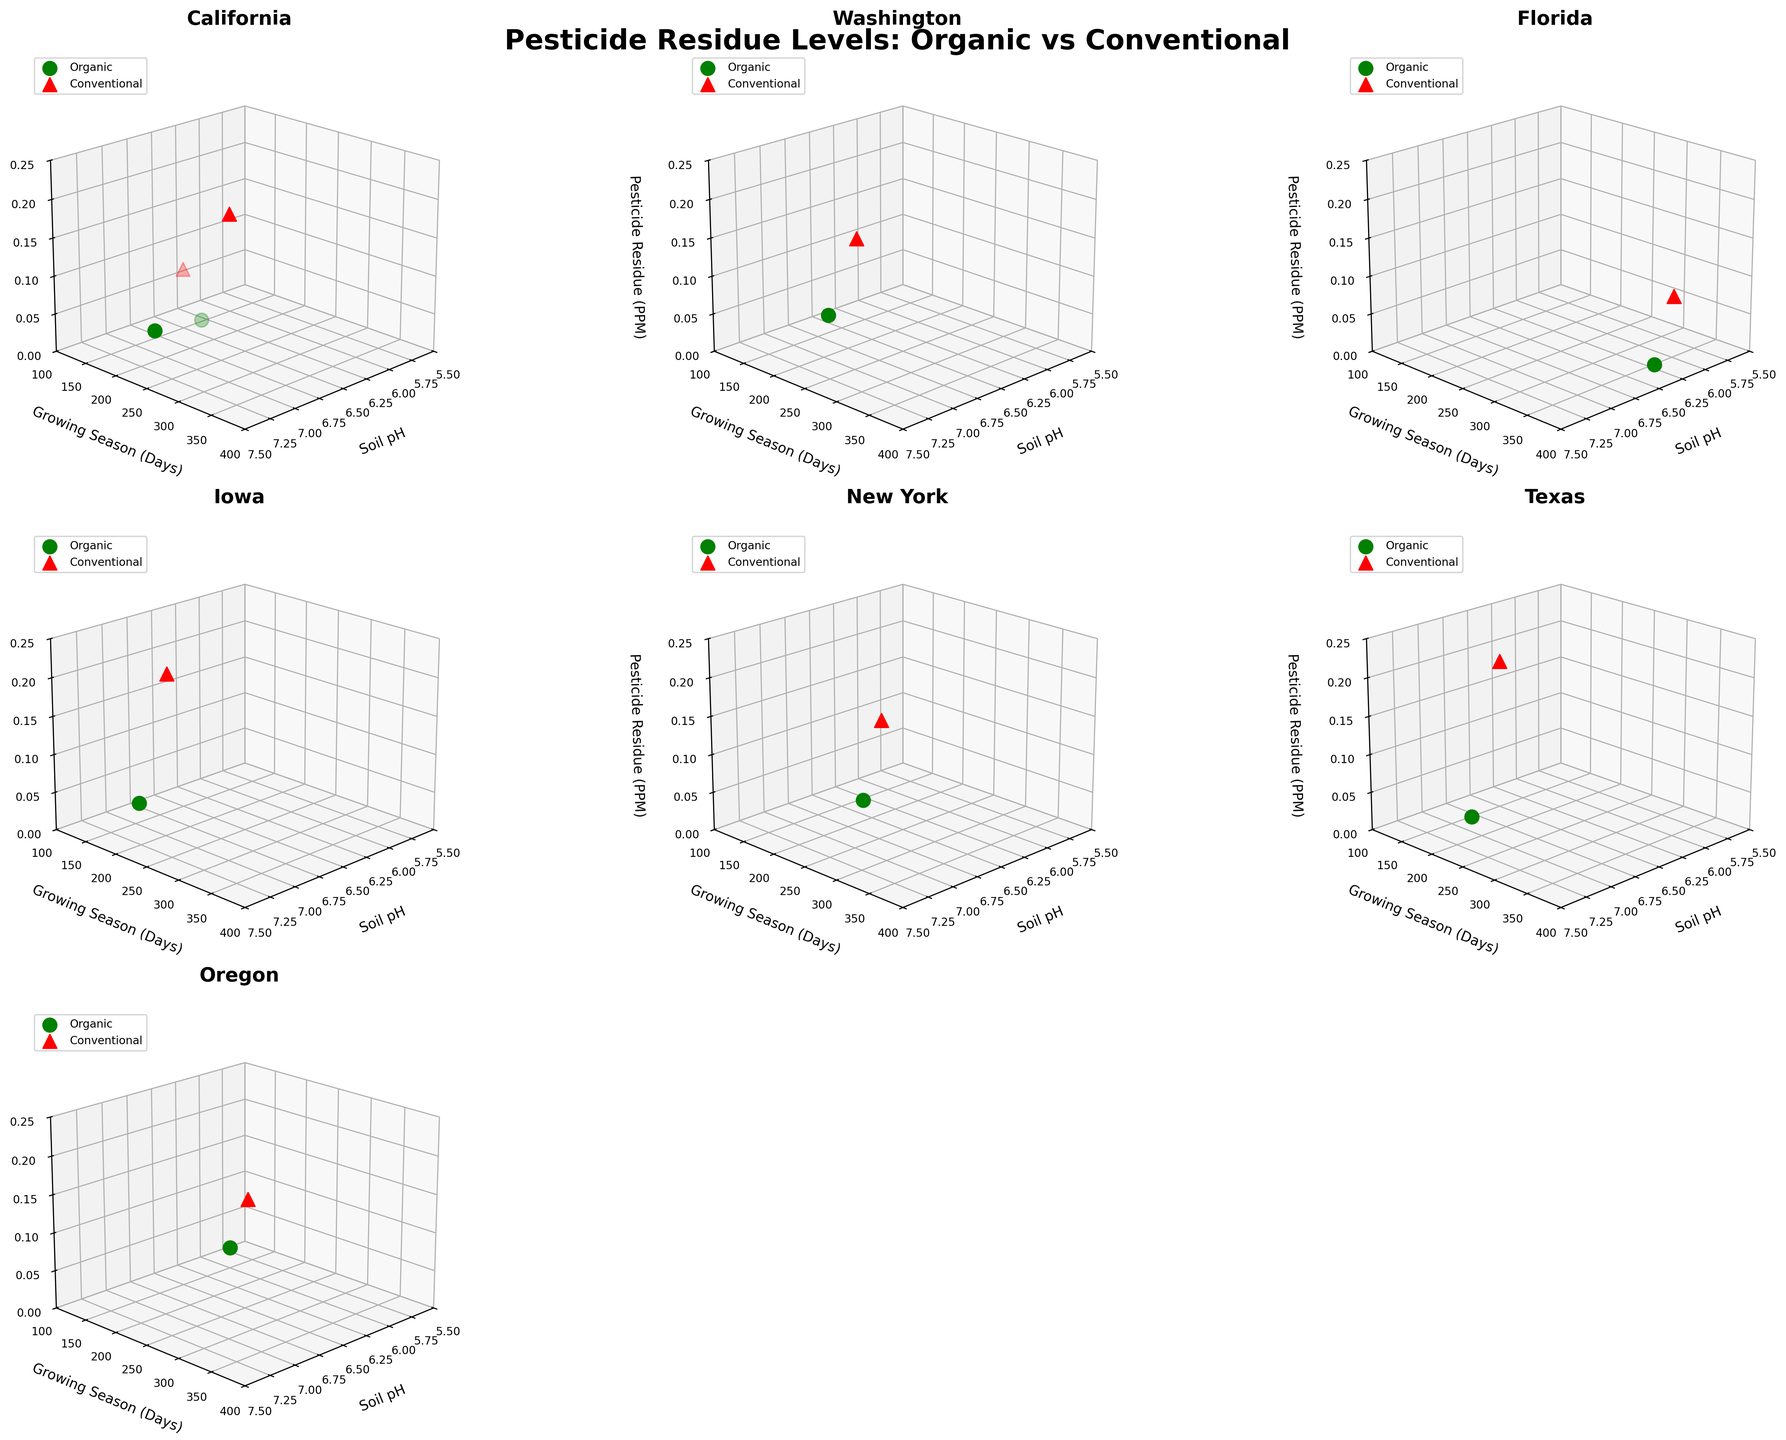what is the title of the overall figure? Look at the center of the figure above the individual subplots, which typically displays the title. Here, it says "Pesticide Residue Levels: Organic vs Conventional".
Answer: Pesticide Residue Levels: Organic vs Conventional Which region has the highest pesticide residue in conventional farming? Identify the subplots showing different regions, then look for the highest red marker which indicates conventional farming. Texas, with a red marker at 0.22 PPM, has the highest pesticide residue.
Answer: Texas What is the range of soil pH values shown for organic produce in Oregon? Locate the Oregon subplot and identify the green markers, which denote organic produce. The green marker in Oregon is at 5.8 pH. Therefore, the range contains one value: 5.8.
Answer: 5.8 Compare the pesticide residue levels in tomatoes between organic and conventional farming in California. Find the California subplot and locate the markers for tomatoes (green for organic, red for conventional). The pesticide residue for organic tomatoes is at 0.01 PPM while for conventional it is at 0.08 PPM.
Answer: 0.01 PPM (organic) vs 0.08 PPM (conventional) How many different regions are visualized in this figure? Count the number of subplots, each uniquely representing a region. There are 7 subplots, each for a different region.
Answer: 7 In which region and farming method is the lowest pesticide residue found? Scan all subplots for the lowest marker position along the pesticide residue (z-axis) for both green and red markers. The lowest values are found in Oregon, Florida, New York, and California for organic farming with a residue of 0.01 PPM.
Answer: Oregon, Florida, New York, California (Organic) What is the average pesticide residue for conventional farming across all regions? Sum the pesticide residues for conventional farming in all regions (0.15 + 0.08 + 0.12 + 0.09 + 0.18 + 0.11 + 0.22 + 0.07) and divide by the number of regions (8).
Answer: (0.15 + 0.08 + 0.12 + 0.09 + 0.18 + 0.11 + 0.22 + 0.07)/8 = 0.1275 PPM Which produce in Washington shows a pesticide residue of 0.03 PPM in organic farming? Locate the Washington subplot and look for green markers at a pesticide residue of 0.03 PPM. This marker corresponds to apples.
Answer: Apples 